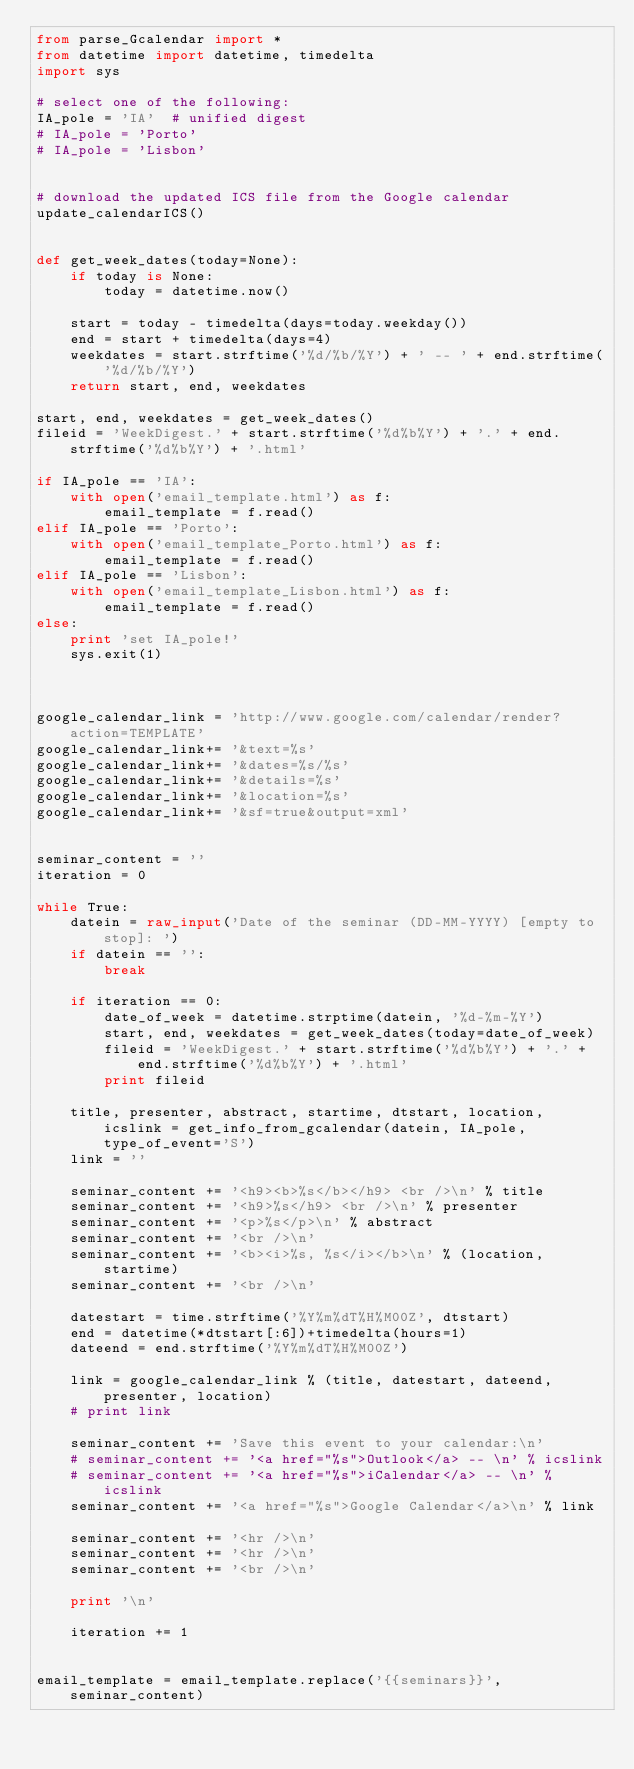Convert code to text. <code><loc_0><loc_0><loc_500><loc_500><_Python_>from parse_Gcalendar import *
from datetime import datetime, timedelta
import sys

# select one of the following:
IA_pole = 'IA'  # unified digest
# IA_pole = 'Porto'
# IA_pole = 'Lisbon'


# download the updated ICS file from the Google calendar
update_calendarICS()


def get_week_dates(today=None):
    if today is None:
        today = datetime.now()

    start = today - timedelta(days=today.weekday())
    end = start + timedelta(days=4)
    weekdates = start.strftime('%d/%b/%Y') + ' -- ' + end.strftime('%d/%b/%Y')
    return start, end, weekdates

start, end, weekdates = get_week_dates()
fileid = 'WeekDigest.' + start.strftime('%d%b%Y') + '.' + end.strftime('%d%b%Y') + '.html'

if IA_pole == 'IA':
    with open('email_template.html') as f:
        email_template = f.read()
elif IA_pole == 'Porto':
    with open('email_template_Porto.html') as f:
        email_template = f.read()
elif IA_pole == 'Lisbon':
    with open('email_template_Lisbon.html') as f:
        email_template = f.read()
else:
    print 'set IA_pole!'
    sys.exit(1)



google_calendar_link = 'http://www.google.com/calendar/render?action=TEMPLATE'
google_calendar_link+= '&text=%s'
google_calendar_link+= '&dates=%s/%s'
google_calendar_link+= '&details=%s'
google_calendar_link+= '&location=%s'
google_calendar_link+= '&sf=true&output=xml'


seminar_content = ''
iteration = 0

while True:
    datein = raw_input('Date of the seminar (DD-MM-YYYY) [empty to stop]: ')
    if datein == '':
        break

    if iteration == 0:
        date_of_week = datetime.strptime(datein, '%d-%m-%Y')
        start, end, weekdates = get_week_dates(today=date_of_week)
        fileid = 'WeekDigest.' + start.strftime('%d%b%Y') + '.' + end.strftime('%d%b%Y') + '.html'
        print fileid

    title, presenter, abstract, startime, dtstart, location, icslink = get_info_from_gcalendar(datein, IA_pole, type_of_event='S')
    link = ''

    seminar_content += '<h9><b>%s</b></h9> <br />\n' % title
    seminar_content += '<h9>%s</h9> <br />\n' % presenter
    seminar_content += '<p>%s</p>\n' % abstract
    seminar_content += '<br />\n'
    seminar_content += '<b><i>%s, %s</i></b>\n' % (location, startime)
    seminar_content += '<br />\n'

    datestart = time.strftime('%Y%m%dT%H%M00Z', dtstart)
    end = datetime(*dtstart[:6])+timedelta(hours=1)
    dateend = end.strftime('%Y%m%dT%H%M00Z')

    link = google_calendar_link % (title, datestart, dateend, presenter, location)
    # print link

    seminar_content += 'Save this event to your calendar:\n'
    # seminar_content += '<a href="%s">Outlook</a> -- \n' % icslink
    # seminar_content += '<a href="%s">iCalendar</a> -- \n' % icslink
    seminar_content += '<a href="%s">Google Calendar</a>\n' % link

    seminar_content += '<hr />\n'
    seminar_content += '<hr />\n'
    seminar_content += '<br />\n'

    print '\n'

    iteration += 1


email_template = email_template.replace('{{seminars}}', seminar_content)</code> 